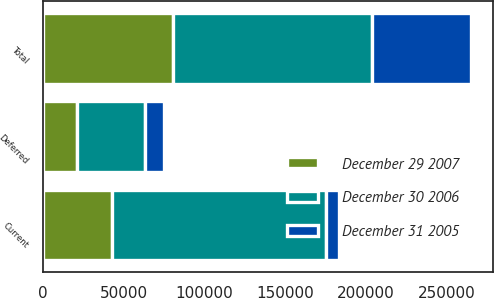<chart> <loc_0><loc_0><loc_500><loc_500><stacked_bar_chart><ecel><fcel>Current<fcel>Deferred<fcel>Total<nl><fcel>December 30 2006<fcel>132452<fcel>42193<fcel>123262<nl><fcel>December 29 2007<fcel>42850<fcel>21153<fcel>80431<nl><fcel>December 31 2005<fcel>7738<fcel>11741<fcel>61381<nl></chart> 